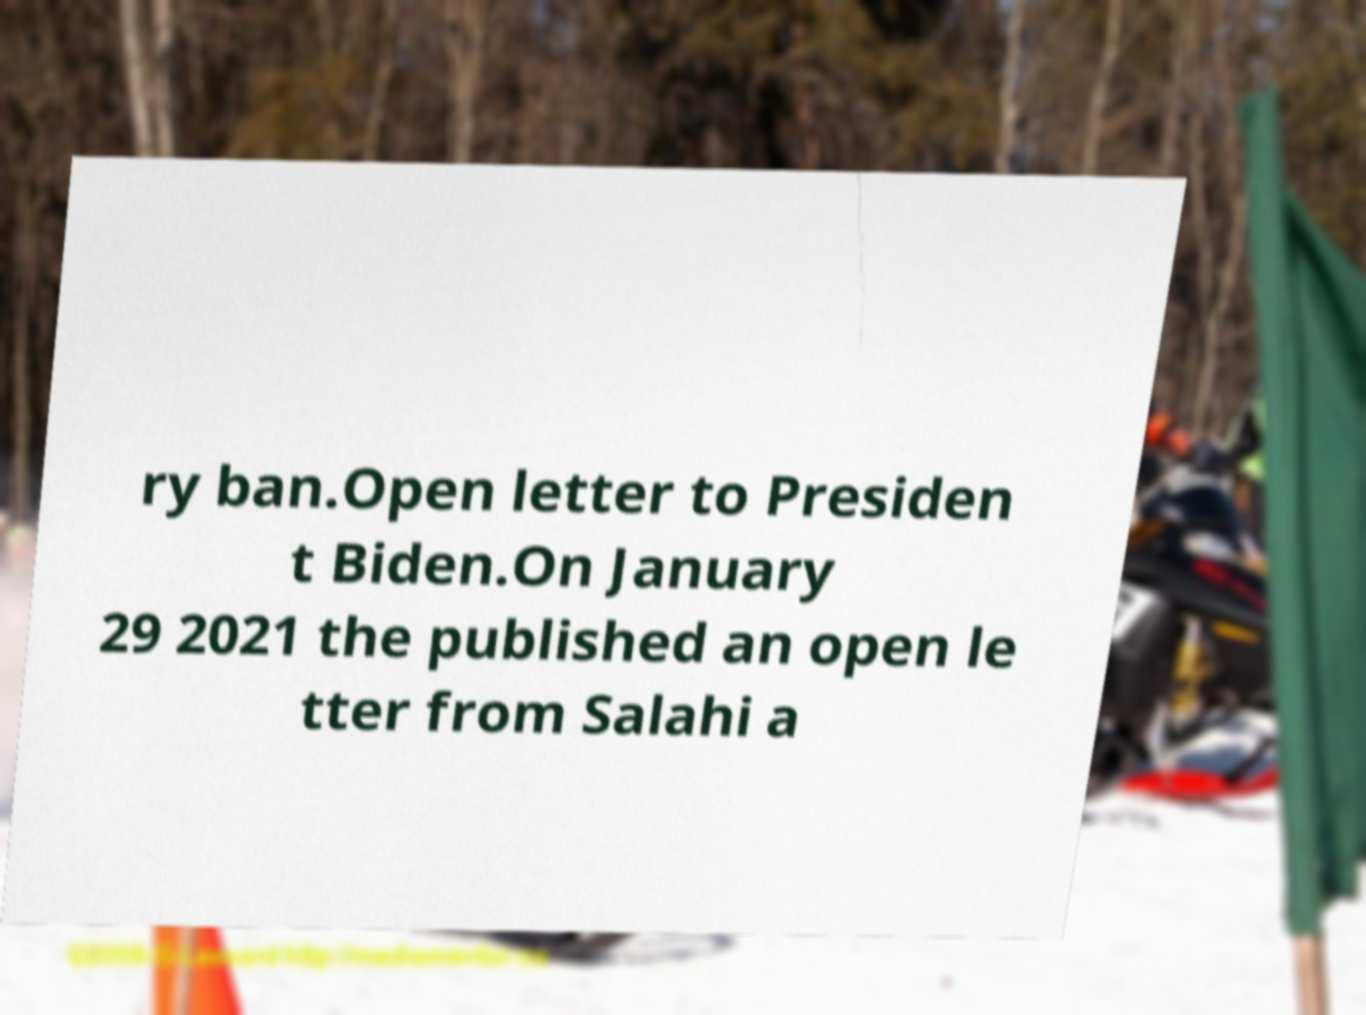Can you read and provide the text displayed in the image?This photo seems to have some interesting text. Can you extract and type it out for me? ry ban.Open letter to Presiden t Biden.On January 29 2021 the published an open le tter from Salahi a 